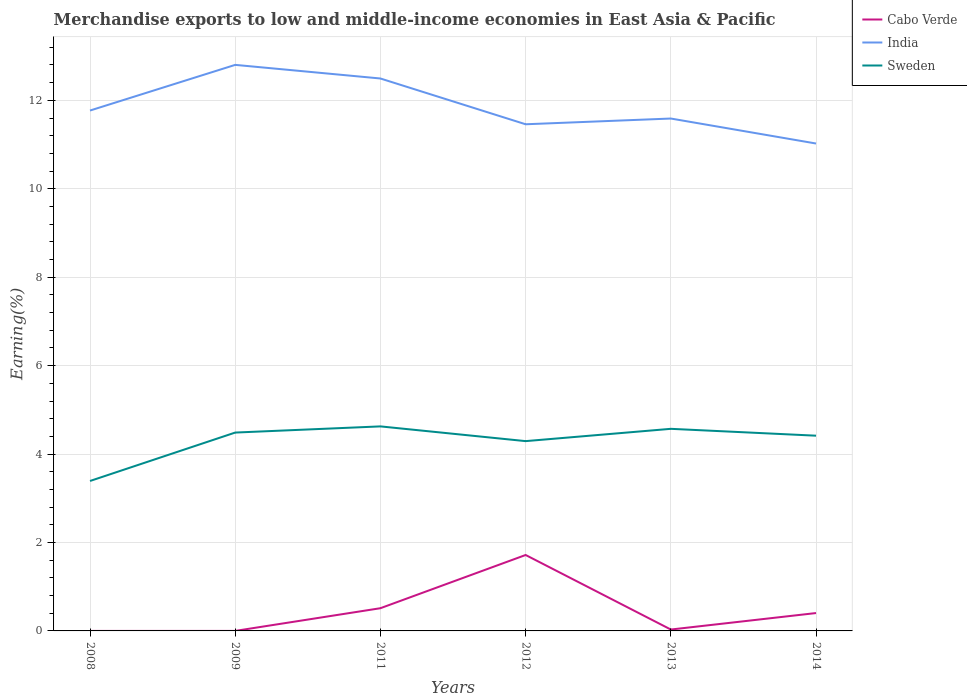Across all years, what is the maximum percentage of amount earned from merchandise exports in Sweden?
Ensure brevity in your answer.  3.39. What is the total percentage of amount earned from merchandise exports in India in the graph?
Your answer should be very brief. -0.13. What is the difference between the highest and the second highest percentage of amount earned from merchandise exports in Cabo Verde?
Provide a succinct answer. 1.72. What is the difference between the highest and the lowest percentage of amount earned from merchandise exports in India?
Your answer should be very brief. 2. Is the percentage of amount earned from merchandise exports in India strictly greater than the percentage of amount earned from merchandise exports in Sweden over the years?
Your answer should be very brief. No. What is the difference between two consecutive major ticks on the Y-axis?
Your answer should be very brief. 2. Are the values on the major ticks of Y-axis written in scientific E-notation?
Offer a terse response. No. Does the graph contain any zero values?
Offer a very short reply. No. Does the graph contain grids?
Provide a succinct answer. Yes. Where does the legend appear in the graph?
Make the answer very short. Top right. How are the legend labels stacked?
Ensure brevity in your answer.  Vertical. What is the title of the graph?
Ensure brevity in your answer.  Merchandise exports to low and middle-income economies in East Asia & Pacific. What is the label or title of the Y-axis?
Your response must be concise. Earning(%). What is the Earning(%) in Cabo Verde in 2008?
Your answer should be compact. 6.60673795000463e-5. What is the Earning(%) of India in 2008?
Keep it short and to the point. 11.77. What is the Earning(%) in Sweden in 2008?
Provide a succinct answer. 3.39. What is the Earning(%) of Cabo Verde in 2009?
Your response must be concise. 0. What is the Earning(%) in India in 2009?
Offer a very short reply. 12.8. What is the Earning(%) in Sweden in 2009?
Provide a short and direct response. 4.49. What is the Earning(%) of Cabo Verde in 2011?
Keep it short and to the point. 0.51. What is the Earning(%) in India in 2011?
Offer a terse response. 12.49. What is the Earning(%) in Sweden in 2011?
Your answer should be compact. 4.63. What is the Earning(%) in Cabo Verde in 2012?
Provide a short and direct response. 1.72. What is the Earning(%) of India in 2012?
Make the answer very short. 11.46. What is the Earning(%) in Sweden in 2012?
Your response must be concise. 4.29. What is the Earning(%) in Cabo Verde in 2013?
Your response must be concise. 0.03. What is the Earning(%) of India in 2013?
Provide a succinct answer. 11.59. What is the Earning(%) of Sweden in 2013?
Your answer should be very brief. 4.57. What is the Earning(%) of Cabo Verde in 2014?
Your answer should be compact. 0.4. What is the Earning(%) of India in 2014?
Offer a very short reply. 11.02. What is the Earning(%) in Sweden in 2014?
Your answer should be very brief. 4.42. Across all years, what is the maximum Earning(%) of Cabo Verde?
Keep it short and to the point. 1.72. Across all years, what is the maximum Earning(%) of India?
Your answer should be compact. 12.8. Across all years, what is the maximum Earning(%) in Sweden?
Your answer should be very brief. 4.63. Across all years, what is the minimum Earning(%) in Cabo Verde?
Your answer should be compact. 6.60673795000463e-5. Across all years, what is the minimum Earning(%) in India?
Provide a short and direct response. 11.02. Across all years, what is the minimum Earning(%) of Sweden?
Provide a succinct answer. 3.39. What is the total Earning(%) of Cabo Verde in the graph?
Keep it short and to the point. 2.67. What is the total Earning(%) of India in the graph?
Your answer should be compact. 71.14. What is the total Earning(%) in Sweden in the graph?
Keep it short and to the point. 25.78. What is the difference between the Earning(%) of Cabo Verde in 2008 and that in 2009?
Your answer should be very brief. -0. What is the difference between the Earning(%) in India in 2008 and that in 2009?
Offer a terse response. -1.03. What is the difference between the Earning(%) of Sweden in 2008 and that in 2009?
Provide a succinct answer. -1.1. What is the difference between the Earning(%) of Cabo Verde in 2008 and that in 2011?
Your answer should be compact. -0.51. What is the difference between the Earning(%) of India in 2008 and that in 2011?
Ensure brevity in your answer.  -0.72. What is the difference between the Earning(%) in Sweden in 2008 and that in 2011?
Provide a short and direct response. -1.23. What is the difference between the Earning(%) in Cabo Verde in 2008 and that in 2012?
Your response must be concise. -1.72. What is the difference between the Earning(%) of India in 2008 and that in 2012?
Give a very brief answer. 0.31. What is the difference between the Earning(%) in Sweden in 2008 and that in 2012?
Give a very brief answer. -0.9. What is the difference between the Earning(%) of Cabo Verde in 2008 and that in 2013?
Provide a succinct answer. -0.03. What is the difference between the Earning(%) in India in 2008 and that in 2013?
Give a very brief answer. 0.18. What is the difference between the Earning(%) of Sweden in 2008 and that in 2013?
Provide a short and direct response. -1.18. What is the difference between the Earning(%) of Cabo Verde in 2008 and that in 2014?
Your answer should be compact. -0.4. What is the difference between the Earning(%) in India in 2008 and that in 2014?
Provide a short and direct response. 0.75. What is the difference between the Earning(%) of Sweden in 2008 and that in 2014?
Your answer should be compact. -1.02. What is the difference between the Earning(%) in Cabo Verde in 2009 and that in 2011?
Offer a very short reply. -0.51. What is the difference between the Earning(%) in India in 2009 and that in 2011?
Make the answer very short. 0.31. What is the difference between the Earning(%) in Sweden in 2009 and that in 2011?
Offer a very short reply. -0.14. What is the difference between the Earning(%) of Cabo Verde in 2009 and that in 2012?
Keep it short and to the point. -1.72. What is the difference between the Earning(%) in India in 2009 and that in 2012?
Keep it short and to the point. 1.34. What is the difference between the Earning(%) of Sweden in 2009 and that in 2012?
Keep it short and to the point. 0.19. What is the difference between the Earning(%) in Cabo Verde in 2009 and that in 2013?
Provide a short and direct response. -0.03. What is the difference between the Earning(%) in India in 2009 and that in 2013?
Your response must be concise. 1.21. What is the difference between the Earning(%) in Sweden in 2009 and that in 2013?
Keep it short and to the point. -0.08. What is the difference between the Earning(%) in Cabo Verde in 2009 and that in 2014?
Provide a short and direct response. -0.4. What is the difference between the Earning(%) of India in 2009 and that in 2014?
Ensure brevity in your answer.  1.78. What is the difference between the Earning(%) of Sweden in 2009 and that in 2014?
Provide a short and direct response. 0.07. What is the difference between the Earning(%) in Cabo Verde in 2011 and that in 2012?
Offer a terse response. -1.2. What is the difference between the Earning(%) of India in 2011 and that in 2012?
Provide a succinct answer. 1.04. What is the difference between the Earning(%) in Cabo Verde in 2011 and that in 2013?
Your answer should be very brief. 0.48. What is the difference between the Earning(%) of India in 2011 and that in 2013?
Offer a very short reply. 0.91. What is the difference between the Earning(%) in Sweden in 2011 and that in 2013?
Provide a short and direct response. 0.06. What is the difference between the Earning(%) in Cabo Verde in 2011 and that in 2014?
Make the answer very short. 0.11. What is the difference between the Earning(%) of India in 2011 and that in 2014?
Offer a very short reply. 1.47. What is the difference between the Earning(%) in Sweden in 2011 and that in 2014?
Offer a terse response. 0.21. What is the difference between the Earning(%) of Cabo Verde in 2012 and that in 2013?
Make the answer very short. 1.69. What is the difference between the Earning(%) of India in 2012 and that in 2013?
Ensure brevity in your answer.  -0.13. What is the difference between the Earning(%) of Sweden in 2012 and that in 2013?
Ensure brevity in your answer.  -0.28. What is the difference between the Earning(%) in Cabo Verde in 2012 and that in 2014?
Offer a terse response. 1.31. What is the difference between the Earning(%) of India in 2012 and that in 2014?
Provide a succinct answer. 0.44. What is the difference between the Earning(%) in Sweden in 2012 and that in 2014?
Make the answer very short. -0.12. What is the difference between the Earning(%) in Cabo Verde in 2013 and that in 2014?
Ensure brevity in your answer.  -0.37. What is the difference between the Earning(%) of India in 2013 and that in 2014?
Your answer should be compact. 0.57. What is the difference between the Earning(%) of Sweden in 2013 and that in 2014?
Provide a short and direct response. 0.15. What is the difference between the Earning(%) in Cabo Verde in 2008 and the Earning(%) in India in 2009?
Offer a very short reply. -12.8. What is the difference between the Earning(%) of Cabo Verde in 2008 and the Earning(%) of Sweden in 2009?
Offer a terse response. -4.49. What is the difference between the Earning(%) of India in 2008 and the Earning(%) of Sweden in 2009?
Your response must be concise. 7.28. What is the difference between the Earning(%) of Cabo Verde in 2008 and the Earning(%) of India in 2011?
Offer a terse response. -12.49. What is the difference between the Earning(%) in Cabo Verde in 2008 and the Earning(%) in Sweden in 2011?
Offer a very short reply. -4.63. What is the difference between the Earning(%) of India in 2008 and the Earning(%) of Sweden in 2011?
Provide a short and direct response. 7.14. What is the difference between the Earning(%) in Cabo Verde in 2008 and the Earning(%) in India in 2012?
Your answer should be very brief. -11.46. What is the difference between the Earning(%) of Cabo Verde in 2008 and the Earning(%) of Sweden in 2012?
Provide a short and direct response. -4.29. What is the difference between the Earning(%) of India in 2008 and the Earning(%) of Sweden in 2012?
Your response must be concise. 7.48. What is the difference between the Earning(%) of Cabo Verde in 2008 and the Earning(%) of India in 2013?
Your answer should be compact. -11.59. What is the difference between the Earning(%) of Cabo Verde in 2008 and the Earning(%) of Sweden in 2013?
Provide a short and direct response. -4.57. What is the difference between the Earning(%) in India in 2008 and the Earning(%) in Sweden in 2013?
Give a very brief answer. 7.2. What is the difference between the Earning(%) in Cabo Verde in 2008 and the Earning(%) in India in 2014?
Your response must be concise. -11.02. What is the difference between the Earning(%) in Cabo Verde in 2008 and the Earning(%) in Sweden in 2014?
Offer a terse response. -4.42. What is the difference between the Earning(%) in India in 2008 and the Earning(%) in Sweden in 2014?
Your response must be concise. 7.35. What is the difference between the Earning(%) of Cabo Verde in 2009 and the Earning(%) of India in 2011?
Make the answer very short. -12.49. What is the difference between the Earning(%) of Cabo Verde in 2009 and the Earning(%) of Sweden in 2011?
Your answer should be very brief. -4.63. What is the difference between the Earning(%) of India in 2009 and the Earning(%) of Sweden in 2011?
Your response must be concise. 8.18. What is the difference between the Earning(%) in Cabo Verde in 2009 and the Earning(%) in India in 2012?
Make the answer very short. -11.46. What is the difference between the Earning(%) of Cabo Verde in 2009 and the Earning(%) of Sweden in 2012?
Make the answer very short. -4.29. What is the difference between the Earning(%) in India in 2009 and the Earning(%) in Sweden in 2012?
Offer a very short reply. 8.51. What is the difference between the Earning(%) of Cabo Verde in 2009 and the Earning(%) of India in 2013?
Ensure brevity in your answer.  -11.59. What is the difference between the Earning(%) in Cabo Verde in 2009 and the Earning(%) in Sweden in 2013?
Keep it short and to the point. -4.57. What is the difference between the Earning(%) of India in 2009 and the Earning(%) of Sweden in 2013?
Provide a succinct answer. 8.23. What is the difference between the Earning(%) of Cabo Verde in 2009 and the Earning(%) of India in 2014?
Offer a terse response. -11.02. What is the difference between the Earning(%) of Cabo Verde in 2009 and the Earning(%) of Sweden in 2014?
Make the answer very short. -4.42. What is the difference between the Earning(%) of India in 2009 and the Earning(%) of Sweden in 2014?
Provide a succinct answer. 8.39. What is the difference between the Earning(%) of Cabo Verde in 2011 and the Earning(%) of India in 2012?
Your response must be concise. -10.95. What is the difference between the Earning(%) of Cabo Verde in 2011 and the Earning(%) of Sweden in 2012?
Make the answer very short. -3.78. What is the difference between the Earning(%) in India in 2011 and the Earning(%) in Sweden in 2012?
Your answer should be very brief. 8.2. What is the difference between the Earning(%) in Cabo Verde in 2011 and the Earning(%) in India in 2013?
Ensure brevity in your answer.  -11.08. What is the difference between the Earning(%) of Cabo Verde in 2011 and the Earning(%) of Sweden in 2013?
Your answer should be very brief. -4.06. What is the difference between the Earning(%) in India in 2011 and the Earning(%) in Sweden in 2013?
Keep it short and to the point. 7.92. What is the difference between the Earning(%) in Cabo Verde in 2011 and the Earning(%) in India in 2014?
Your answer should be compact. -10.51. What is the difference between the Earning(%) in Cabo Verde in 2011 and the Earning(%) in Sweden in 2014?
Make the answer very short. -3.9. What is the difference between the Earning(%) of India in 2011 and the Earning(%) of Sweden in 2014?
Make the answer very short. 8.08. What is the difference between the Earning(%) in Cabo Verde in 2012 and the Earning(%) in India in 2013?
Keep it short and to the point. -9.87. What is the difference between the Earning(%) in Cabo Verde in 2012 and the Earning(%) in Sweden in 2013?
Ensure brevity in your answer.  -2.85. What is the difference between the Earning(%) in India in 2012 and the Earning(%) in Sweden in 2013?
Provide a short and direct response. 6.89. What is the difference between the Earning(%) in Cabo Verde in 2012 and the Earning(%) in India in 2014?
Your answer should be compact. -9.31. What is the difference between the Earning(%) of Cabo Verde in 2012 and the Earning(%) of Sweden in 2014?
Give a very brief answer. -2.7. What is the difference between the Earning(%) of India in 2012 and the Earning(%) of Sweden in 2014?
Your response must be concise. 7.04. What is the difference between the Earning(%) in Cabo Verde in 2013 and the Earning(%) in India in 2014?
Offer a very short reply. -10.99. What is the difference between the Earning(%) in Cabo Verde in 2013 and the Earning(%) in Sweden in 2014?
Offer a terse response. -4.38. What is the difference between the Earning(%) of India in 2013 and the Earning(%) of Sweden in 2014?
Give a very brief answer. 7.17. What is the average Earning(%) in Cabo Verde per year?
Give a very brief answer. 0.44. What is the average Earning(%) of India per year?
Your answer should be very brief. 11.86. What is the average Earning(%) in Sweden per year?
Ensure brevity in your answer.  4.3. In the year 2008, what is the difference between the Earning(%) in Cabo Verde and Earning(%) in India?
Keep it short and to the point. -11.77. In the year 2008, what is the difference between the Earning(%) in Cabo Verde and Earning(%) in Sweden?
Your response must be concise. -3.39. In the year 2008, what is the difference between the Earning(%) in India and Earning(%) in Sweden?
Your response must be concise. 8.38. In the year 2009, what is the difference between the Earning(%) of Cabo Verde and Earning(%) of India?
Make the answer very short. -12.8. In the year 2009, what is the difference between the Earning(%) in Cabo Verde and Earning(%) in Sweden?
Your answer should be compact. -4.49. In the year 2009, what is the difference between the Earning(%) of India and Earning(%) of Sweden?
Make the answer very short. 8.32. In the year 2011, what is the difference between the Earning(%) in Cabo Verde and Earning(%) in India?
Offer a very short reply. -11.98. In the year 2011, what is the difference between the Earning(%) of Cabo Verde and Earning(%) of Sweden?
Ensure brevity in your answer.  -4.11. In the year 2011, what is the difference between the Earning(%) in India and Earning(%) in Sweden?
Ensure brevity in your answer.  7.87. In the year 2012, what is the difference between the Earning(%) in Cabo Verde and Earning(%) in India?
Your response must be concise. -9.74. In the year 2012, what is the difference between the Earning(%) in Cabo Verde and Earning(%) in Sweden?
Your answer should be compact. -2.58. In the year 2012, what is the difference between the Earning(%) of India and Earning(%) of Sweden?
Your response must be concise. 7.17. In the year 2013, what is the difference between the Earning(%) of Cabo Verde and Earning(%) of India?
Your response must be concise. -11.56. In the year 2013, what is the difference between the Earning(%) of Cabo Verde and Earning(%) of Sweden?
Offer a terse response. -4.54. In the year 2013, what is the difference between the Earning(%) of India and Earning(%) of Sweden?
Ensure brevity in your answer.  7.02. In the year 2014, what is the difference between the Earning(%) of Cabo Verde and Earning(%) of India?
Offer a very short reply. -10.62. In the year 2014, what is the difference between the Earning(%) in Cabo Verde and Earning(%) in Sweden?
Your answer should be compact. -4.01. In the year 2014, what is the difference between the Earning(%) of India and Earning(%) of Sweden?
Offer a very short reply. 6.61. What is the ratio of the Earning(%) of Cabo Verde in 2008 to that in 2009?
Your answer should be very brief. 0.18. What is the ratio of the Earning(%) in India in 2008 to that in 2009?
Offer a very short reply. 0.92. What is the ratio of the Earning(%) of Sweden in 2008 to that in 2009?
Ensure brevity in your answer.  0.76. What is the ratio of the Earning(%) of India in 2008 to that in 2011?
Keep it short and to the point. 0.94. What is the ratio of the Earning(%) of Sweden in 2008 to that in 2011?
Offer a very short reply. 0.73. What is the ratio of the Earning(%) of Cabo Verde in 2008 to that in 2012?
Offer a terse response. 0. What is the ratio of the Earning(%) of India in 2008 to that in 2012?
Your response must be concise. 1.03. What is the ratio of the Earning(%) in Sweden in 2008 to that in 2012?
Ensure brevity in your answer.  0.79. What is the ratio of the Earning(%) of Cabo Verde in 2008 to that in 2013?
Keep it short and to the point. 0. What is the ratio of the Earning(%) of India in 2008 to that in 2013?
Your response must be concise. 1.02. What is the ratio of the Earning(%) in Sweden in 2008 to that in 2013?
Your answer should be compact. 0.74. What is the ratio of the Earning(%) of Cabo Verde in 2008 to that in 2014?
Keep it short and to the point. 0. What is the ratio of the Earning(%) in India in 2008 to that in 2014?
Make the answer very short. 1.07. What is the ratio of the Earning(%) in Sweden in 2008 to that in 2014?
Your answer should be very brief. 0.77. What is the ratio of the Earning(%) of Cabo Verde in 2009 to that in 2011?
Give a very brief answer. 0. What is the ratio of the Earning(%) of India in 2009 to that in 2011?
Your answer should be compact. 1.02. What is the ratio of the Earning(%) in Sweden in 2009 to that in 2011?
Give a very brief answer. 0.97. What is the ratio of the Earning(%) of Cabo Verde in 2009 to that in 2012?
Offer a terse response. 0. What is the ratio of the Earning(%) in India in 2009 to that in 2012?
Your response must be concise. 1.12. What is the ratio of the Earning(%) in Sweden in 2009 to that in 2012?
Your response must be concise. 1.05. What is the ratio of the Earning(%) of Cabo Verde in 2009 to that in 2013?
Your answer should be compact. 0.01. What is the ratio of the Earning(%) in India in 2009 to that in 2013?
Provide a short and direct response. 1.1. What is the ratio of the Earning(%) of Sweden in 2009 to that in 2013?
Your response must be concise. 0.98. What is the ratio of the Earning(%) of Cabo Verde in 2009 to that in 2014?
Ensure brevity in your answer.  0. What is the ratio of the Earning(%) in India in 2009 to that in 2014?
Your answer should be very brief. 1.16. What is the ratio of the Earning(%) of Cabo Verde in 2011 to that in 2012?
Provide a short and direct response. 0.3. What is the ratio of the Earning(%) in India in 2011 to that in 2012?
Ensure brevity in your answer.  1.09. What is the ratio of the Earning(%) of Sweden in 2011 to that in 2012?
Your response must be concise. 1.08. What is the ratio of the Earning(%) of Cabo Verde in 2011 to that in 2013?
Offer a terse response. 16.35. What is the ratio of the Earning(%) in India in 2011 to that in 2013?
Ensure brevity in your answer.  1.08. What is the ratio of the Earning(%) of Sweden in 2011 to that in 2013?
Give a very brief answer. 1.01. What is the ratio of the Earning(%) in Cabo Verde in 2011 to that in 2014?
Offer a terse response. 1.27. What is the ratio of the Earning(%) in India in 2011 to that in 2014?
Provide a short and direct response. 1.13. What is the ratio of the Earning(%) of Sweden in 2011 to that in 2014?
Keep it short and to the point. 1.05. What is the ratio of the Earning(%) in Cabo Verde in 2012 to that in 2013?
Give a very brief answer. 54.65. What is the ratio of the Earning(%) in Sweden in 2012 to that in 2013?
Ensure brevity in your answer.  0.94. What is the ratio of the Earning(%) of Cabo Verde in 2012 to that in 2014?
Your answer should be compact. 4.25. What is the ratio of the Earning(%) in India in 2012 to that in 2014?
Your answer should be very brief. 1.04. What is the ratio of the Earning(%) in Sweden in 2012 to that in 2014?
Make the answer very short. 0.97. What is the ratio of the Earning(%) in Cabo Verde in 2013 to that in 2014?
Ensure brevity in your answer.  0.08. What is the ratio of the Earning(%) of India in 2013 to that in 2014?
Offer a terse response. 1.05. What is the ratio of the Earning(%) in Sweden in 2013 to that in 2014?
Give a very brief answer. 1.04. What is the difference between the highest and the second highest Earning(%) of Cabo Verde?
Offer a very short reply. 1.2. What is the difference between the highest and the second highest Earning(%) in India?
Offer a very short reply. 0.31. What is the difference between the highest and the second highest Earning(%) of Sweden?
Make the answer very short. 0.06. What is the difference between the highest and the lowest Earning(%) in Cabo Verde?
Give a very brief answer. 1.72. What is the difference between the highest and the lowest Earning(%) of India?
Provide a succinct answer. 1.78. What is the difference between the highest and the lowest Earning(%) of Sweden?
Provide a succinct answer. 1.23. 